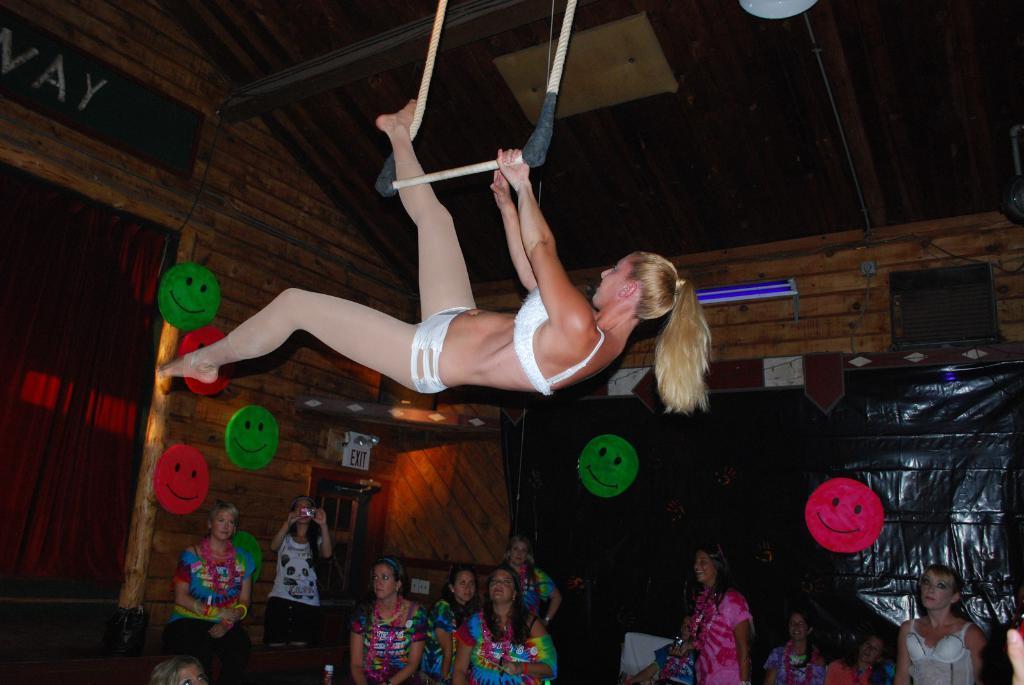How would you summarize this image in a sentence or two? In this picture there is a woman who is wearing white dress and she is doing stunt on the rope. At the bottom I can see many peoples were watching the stunt. On the bottom left there is a woman who is wearing white t-shirt and black trouser. She is holding a camera. Beside her I can see the door. On the wall I can see some smiley stickers. On the top right there is a light which is hanging from the roof. 